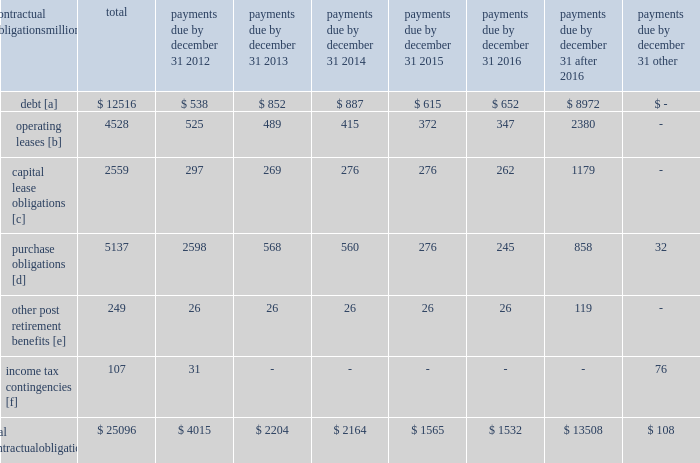The railroad collected approximately $ 18.8 billion and $ 16.3 billion of receivables during the years ended december 31 , 2011 and 2010 , respectively .
Upri used certain of these proceeds to purchase new receivables under the facility .
The costs of the receivables securitization facility include interest , which will vary based on prevailing commercial paper rates , program fees paid to banks , commercial paper issuing costs , and fees for unused commitment availability .
The costs of the receivables securitization facility are included in interest expense and were $ 4 million and $ 6 million for 2011 and 2010 , respectively .
Prior to adoption of the new accounting standard , the costs of the receivables securitization facility were included in other income and were $ 9 million for 2009 .
The investors have no recourse to the railroad 2019s other assets , except for customary warranty and indemnity claims .
Creditors of the railroad do not have recourse to the assets of upri .
In august 2011 , the receivables securitization facility was renewed for an additional 364-day period at comparable terms and conditions .
Contractual obligations and commercial commitments as described in the notes to the consolidated financial statements and as referenced in the tables below , we have contractual obligations and commercial commitments that may affect our financial condition .
Based on our assessment of the underlying provisions and circumstances of our contractual obligations and commercial commitments , including material sources of off-balance sheet and structured finance arrangements , other than the risks that we and other similarly situated companies face with respect to the condition of the capital markets ( as described in item 1a of part ii of this report ) , there is no known trend , demand , commitment , event , or uncertainty that is reasonably likely to occur that would have a material adverse effect on our consolidated results of operations , financial condition , or liquidity .
In addition , our commercial obligations , financings , and commitments are customary transactions that are similar to those of other comparable corporations , particularly within the transportation industry .
The tables identify material obligations and commitments as of december 31 , 2011 : payments due by december 31 , contractual obligations after millions total 2012 2013 2014 2015 2016 2016 other .
[a] excludes capital lease obligations of $ 1874 million and unamortized discount of $ 364 million .
Includes an interest component of $ 5120 million .
[b] includes leases for locomotives , freight cars , other equipment , and real estate .
[c] represents total obligations , including interest component of $ 685 million .
[d] purchase obligations include locomotive maintenance contracts ; purchase commitments for fuel purchases , locomotives , ties , ballast , and rail ; and agreements to purchase other goods and services .
For amounts where we cannot reasonably estimate the year of settlement , they are reflected in the other column .
[e] includes estimated other post retirement , medical , and life insurance payments and payments made under the unfunded pension plan for the next ten years .
No amounts are included for funded pension obligations as no contributions are currently required .
[f] future cash flows for income tax contingencies reflect the recorded liability for unrecognized tax benefits , including interest and penalties , as of december 31 , 2011 .
Where we can reasonably estimate the years in which these liabilities may be settled , this is shown in the table .
For amounts where we cannot reasonably estimate the year of settlement , they are reflected in the other column. .
Assuming a 120 day inventory turn , how of the receivables balance at december 31 , 2010 , was collected in q1 2011 in billions? 
Rationale: 120 days = 4 months . 4 mos = 3 turns per year .
Computations: (16.3 / 3)
Answer: 5.43333. 